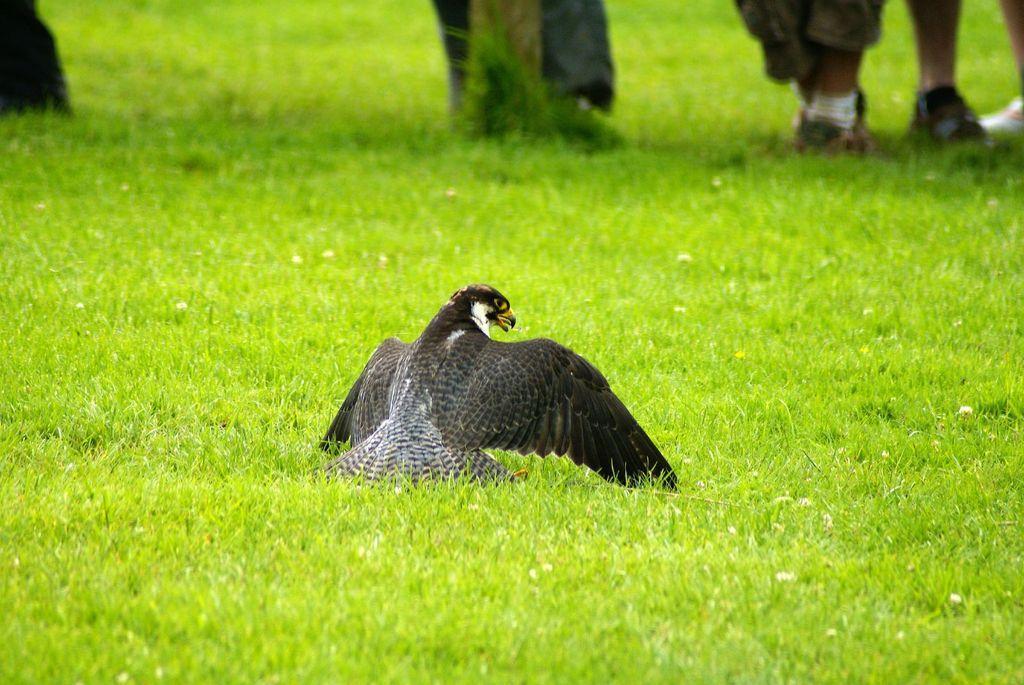Describe this image in one or two sentences. In the center of the picture there is a eagle. In the picture there is grass. At the top there are persons legs and a pole. 